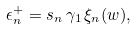Convert formula to latex. <formula><loc_0><loc_0><loc_500><loc_500>\epsilon ^ { + } _ { n } = s _ { n } \, \gamma _ { 1 } \, \xi _ { n } ( w ) ,</formula> 